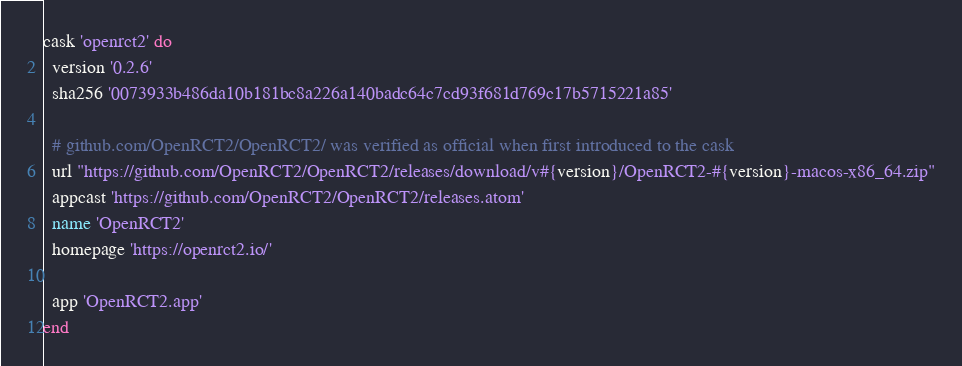<code> <loc_0><loc_0><loc_500><loc_500><_Ruby_>cask 'openrct2' do
  version '0.2.6'
  sha256 '0073933b486da10b181bc8a226a140badc64c7cd93f681d769c17b5715221a85'

  # github.com/OpenRCT2/OpenRCT2/ was verified as official when first introduced to the cask
  url "https://github.com/OpenRCT2/OpenRCT2/releases/download/v#{version}/OpenRCT2-#{version}-macos-x86_64.zip"
  appcast 'https://github.com/OpenRCT2/OpenRCT2/releases.atom'
  name 'OpenRCT2'
  homepage 'https://openrct2.io/'

  app 'OpenRCT2.app'
end
</code> 